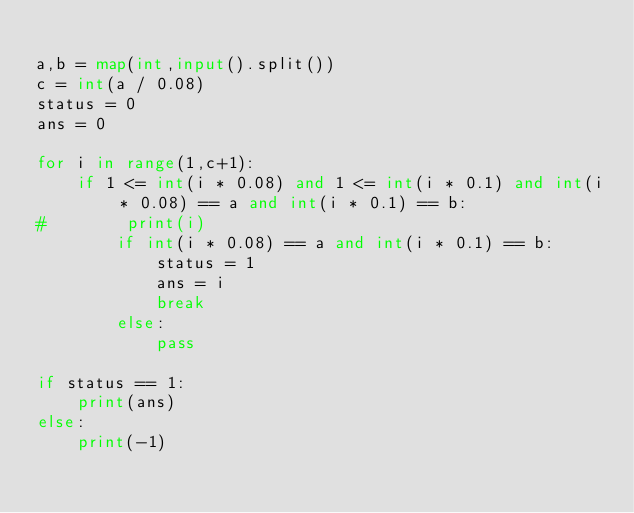Convert code to text. <code><loc_0><loc_0><loc_500><loc_500><_Python_>
a,b = map(int,input().split())
c = int(a / 0.08)
status = 0
ans = 0

for i in range(1,c+1):
    if 1 <= int(i * 0.08) and 1 <= int(i * 0.1) and int(i * 0.08) == a and int(i * 0.1) == b:
#        print(i)
        if int(i * 0.08) == a and int(i * 0.1) == b:
            status = 1
            ans = i
            break
        else:
            pass

if status == 1:
    print(ans)
else:
    print(-1)
</code> 